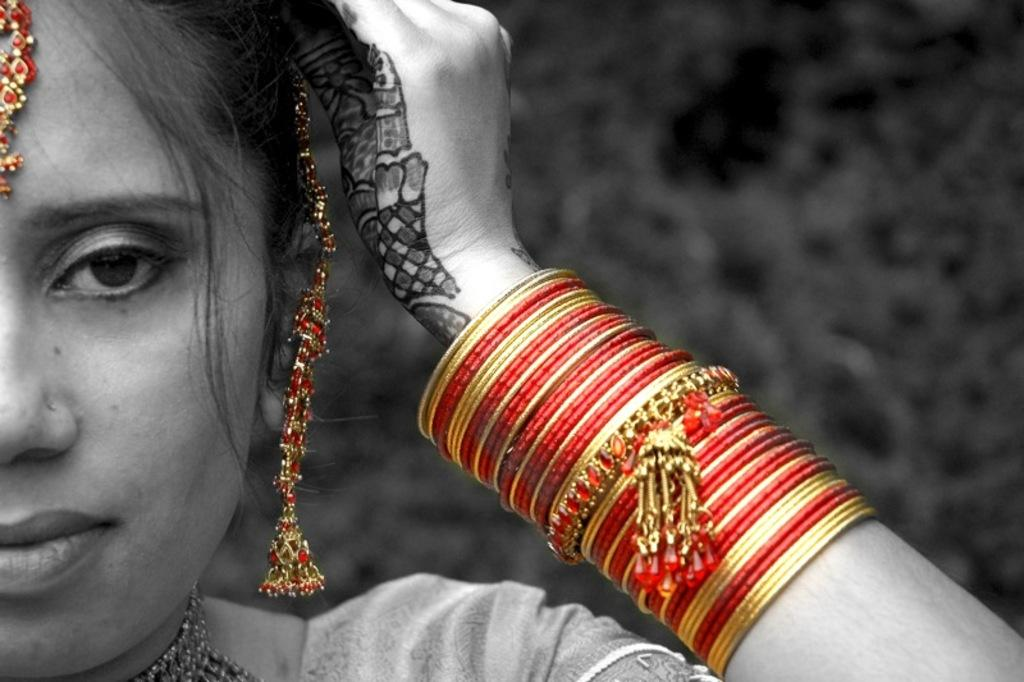Who is present in the image? There is a woman in the image. What accessories is the woman wearing on her arms? The woman is wearing bangles in the image. What type of accessories is the woman wearing in general? The woman is wearing jewelry in the image. What type of hydrant can be seen in the image? There is no hydrant present in the image. What type of battle is taking place in the image? There is no battle present in the image. 